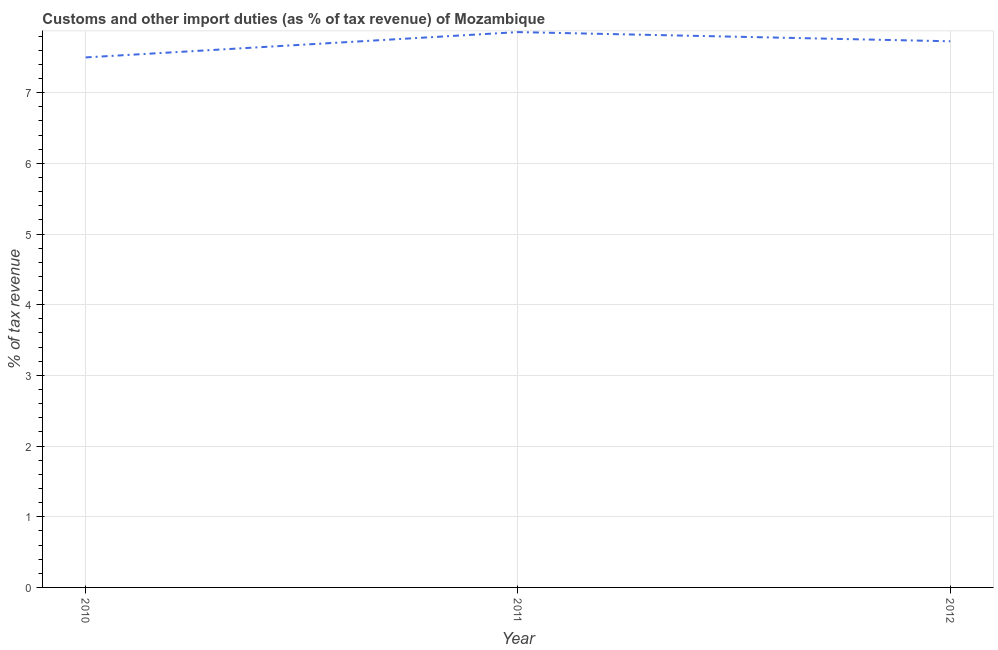What is the customs and other import duties in 2012?
Ensure brevity in your answer.  7.73. Across all years, what is the maximum customs and other import duties?
Offer a very short reply. 7.86. Across all years, what is the minimum customs and other import duties?
Provide a succinct answer. 7.5. In which year was the customs and other import duties maximum?
Your answer should be very brief. 2011. In which year was the customs and other import duties minimum?
Give a very brief answer. 2010. What is the sum of the customs and other import duties?
Ensure brevity in your answer.  23.08. What is the difference between the customs and other import duties in 2010 and 2012?
Provide a succinct answer. -0.23. What is the average customs and other import duties per year?
Your answer should be compact. 7.69. What is the median customs and other import duties?
Give a very brief answer. 7.73. Do a majority of the years between 2010 and 2012 (inclusive) have customs and other import duties greater than 7.6 %?
Offer a terse response. Yes. What is the ratio of the customs and other import duties in 2010 to that in 2011?
Your answer should be compact. 0.95. Is the difference between the customs and other import duties in 2010 and 2012 greater than the difference between any two years?
Your answer should be compact. No. What is the difference between the highest and the second highest customs and other import duties?
Your answer should be very brief. 0.13. What is the difference between the highest and the lowest customs and other import duties?
Ensure brevity in your answer.  0.36. In how many years, is the customs and other import duties greater than the average customs and other import duties taken over all years?
Ensure brevity in your answer.  2. How many lines are there?
Offer a terse response. 1. How many years are there in the graph?
Keep it short and to the point. 3. Are the values on the major ticks of Y-axis written in scientific E-notation?
Give a very brief answer. No. Does the graph contain grids?
Offer a very short reply. Yes. What is the title of the graph?
Your answer should be very brief. Customs and other import duties (as % of tax revenue) of Mozambique. What is the label or title of the X-axis?
Your response must be concise. Year. What is the label or title of the Y-axis?
Provide a short and direct response. % of tax revenue. What is the % of tax revenue of 2010?
Offer a very short reply. 7.5. What is the % of tax revenue of 2011?
Your answer should be very brief. 7.86. What is the % of tax revenue of 2012?
Your answer should be very brief. 7.73. What is the difference between the % of tax revenue in 2010 and 2011?
Offer a terse response. -0.36. What is the difference between the % of tax revenue in 2010 and 2012?
Provide a short and direct response. -0.23. What is the difference between the % of tax revenue in 2011 and 2012?
Provide a short and direct response. 0.13. What is the ratio of the % of tax revenue in 2010 to that in 2011?
Your answer should be compact. 0.95. What is the ratio of the % of tax revenue in 2010 to that in 2012?
Your answer should be compact. 0.97. 